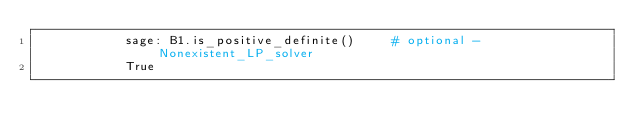Convert code to text. <code><loc_0><loc_0><loc_500><loc_500><_Cython_>            sage: B1.is_positive_definite()     # optional - Nonexistent_LP_solver
            True</code> 